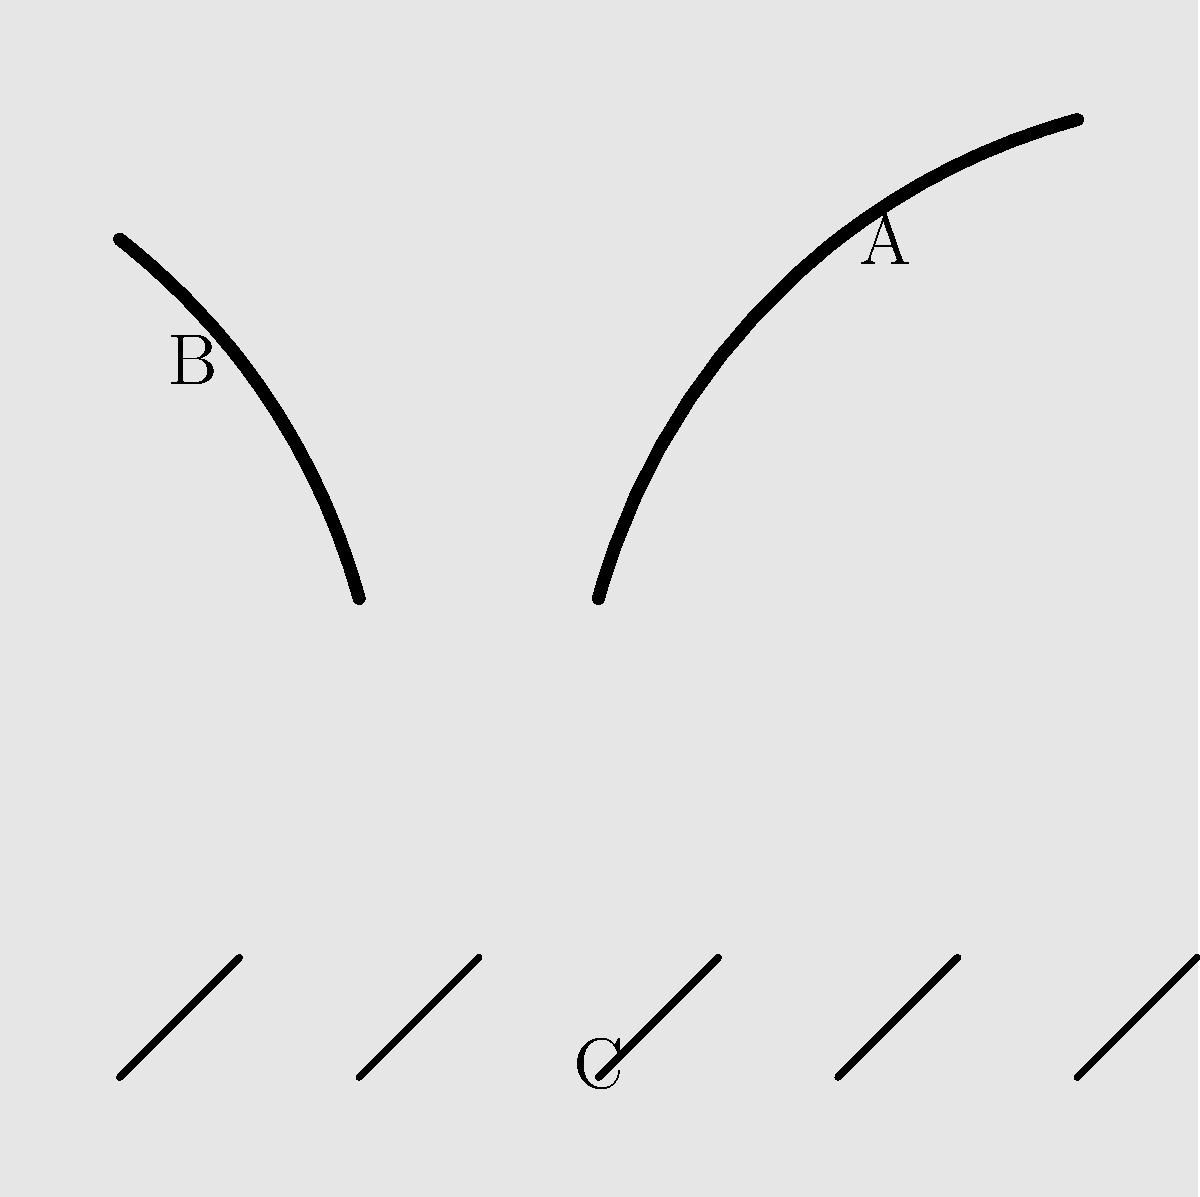In the X-ray image above, identify the animal parts commonly trafficked in the illegal wildlife trade. Match the labels A, B, C, and D to the correct animal parts. To identify the animal parts in the X-ray image, we need to analyze the shapes and characteristics of each labeled item:

1. Item A: This curved, elongated shape resembles an elephant tusk. Elephant ivory is one of the most commonly trafficked wildlife products.

2. Item B: The curved, conical shape is characteristic of a rhino horn. Rhino horns are highly sought after in illegal wildlife trade.

3. Item C: These small, elongated shapes arranged in a pattern are likely tiger bones. Tiger parts, including bones, are trafficked for traditional medicine.

4. Item D: The overlapping, scale-like patterns represent pangolin scales. Pangolins are the most trafficked mammals in the world, primarily for their scales.

By matching these characteristics to our knowledge of commonly trafficked wildlife products, we can identify each item:

A - Elephant tusk
B - Rhino horn
C - Tiger bones
D - Pangolin scales
Answer: A: Elephant tusk, B: Rhino horn, C: Tiger bones, D: Pangolin scales 